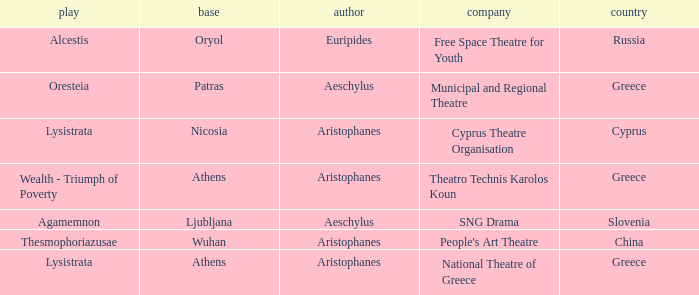What is the play when the company is national theatre of greece? Lysistrata. 